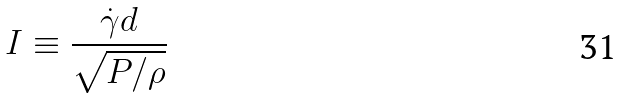Convert formula to latex. <formula><loc_0><loc_0><loc_500><loc_500>I \equiv \frac { \dot { \gamma } d } { \sqrt { P / \rho } }</formula> 